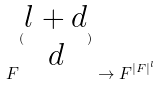Convert formula to latex. <formula><loc_0><loc_0><loc_500><loc_500>F ^ { ( \begin{matrix} l + d \\ d \end{matrix} ) } \rightarrow F ^ { | F | ^ { l } }</formula> 